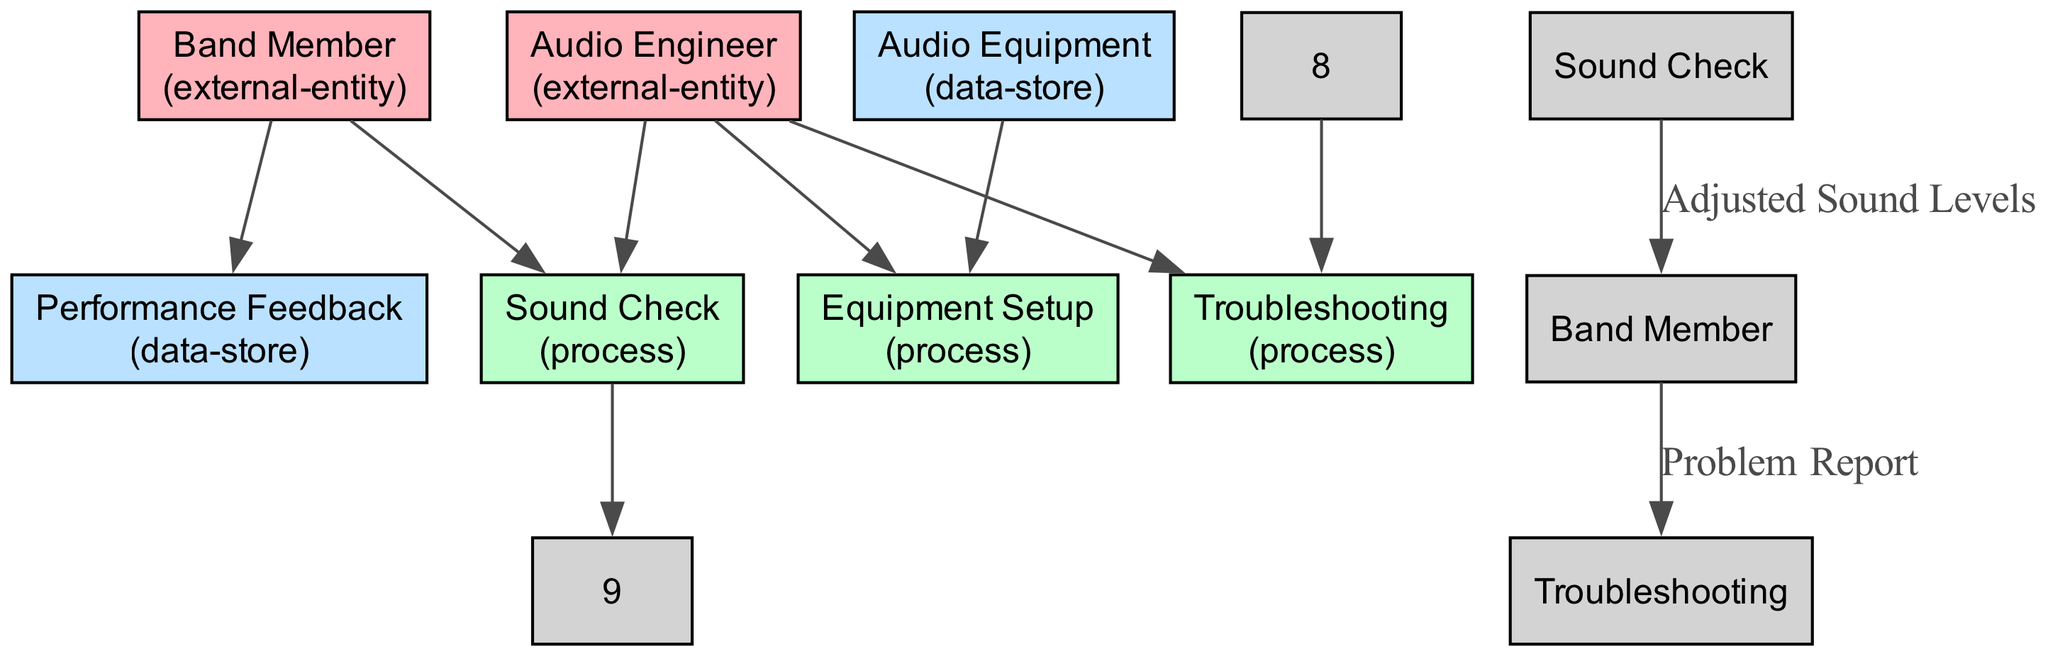What is the main role of the Audio Engineer? The Audio Engineer is identified as a professional responsible for setting up and managing audio equipment, as noted in the diagram.
Answer: Professional responsible for setting up and managing audio equipment How many processes are represented in the diagram? Counting the processes labeled in the diagram—Sound Check, Equipment Setup, and Troubleshooting—there are three distinct processes.
Answer: Three What is the output of the Sound Check process? The output of the Sound Check process is specified as Adjusted Sound Levels, directly indicated in the diagram.
Answer: Adjusted Sound Levels Which external entity initiates the Problem Report? The diagram shows the Band Member as the source of the Problem Report, indicating they are the ones who report any issues encountered during the performance.
Answer: Band Member What does the Equipment Setup process produce? The Equipment Setup process has two outputs: Pre-performance Assessment and Connected Equipment, as detailed in the diagram.
Answer: Pre-performance Assessment, Connected Equipment Which data-store is used for recording feedback? The diagram specifies Performance Feedback as the data-store utilized for capturing feedback from band members and the audience regarding audio quality.
Answer: Performance Feedback What inputs does the Troubleshooting process require? The inputs needed for the Troubleshooting process include the Audio Engineer and a Problem Report, both of which are identified in the diagram.
Answer: Audio Engineer, Problem Report How many data flows are present in the diagram? The diagram shows four data flows: Problem Report, Adjusted Sound Levels, and the two processes Equipment Setup and Sound Check, leading to specific outputs.
Answer: Four 